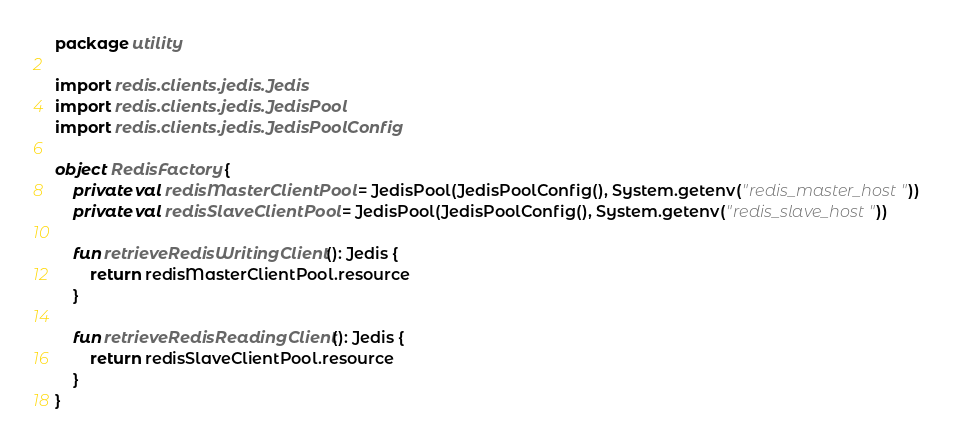Convert code to text. <code><loc_0><loc_0><loc_500><loc_500><_Kotlin_>package utility

import redis.clients.jedis.Jedis
import redis.clients.jedis.JedisPool
import redis.clients.jedis.JedisPoolConfig

object RedisFactory {
    private val redisMasterClientPool = JedisPool(JedisPoolConfig(), System.getenv("redis_master_host"))
    private val redisSlaveClientPool = JedisPool(JedisPoolConfig(), System.getenv("redis_slave_host"))

    fun retrieveRedisWritingClient(): Jedis {
        return redisMasterClientPool.resource
    }

    fun retrieveRedisReadingClient(): Jedis {
        return redisSlaveClientPool.resource
    }
}
</code> 